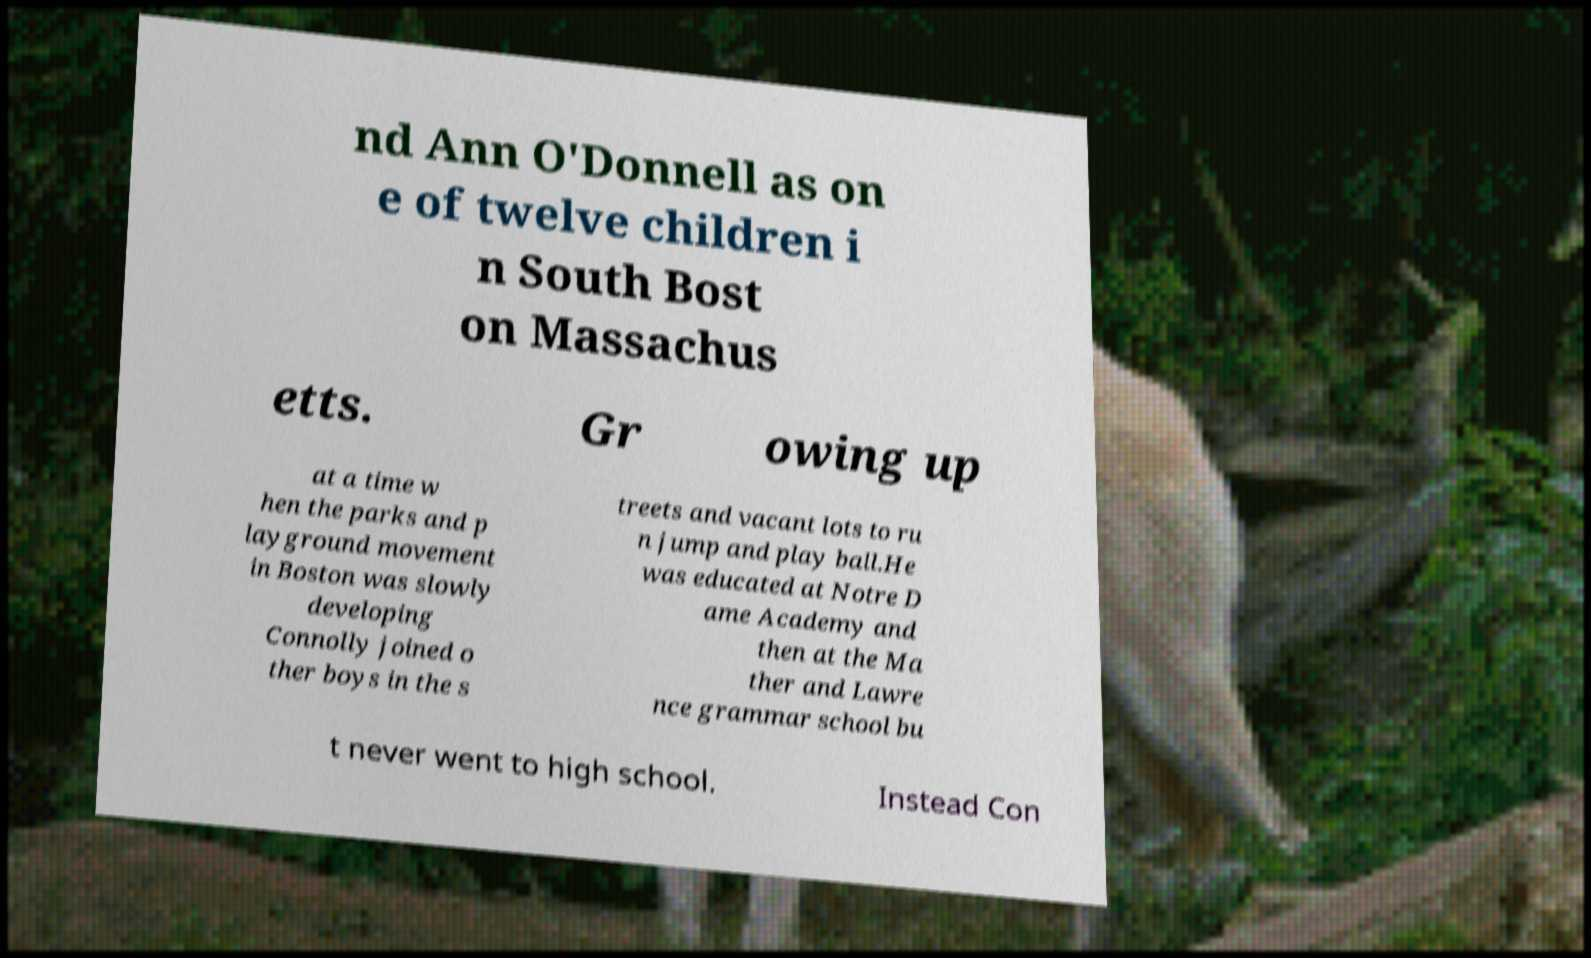I need the written content from this picture converted into text. Can you do that? nd Ann O'Donnell as on e of twelve children i n South Bost on Massachus etts. Gr owing up at a time w hen the parks and p layground movement in Boston was slowly developing Connolly joined o ther boys in the s treets and vacant lots to ru n jump and play ball.He was educated at Notre D ame Academy and then at the Ma ther and Lawre nce grammar school bu t never went to high school. Instead Con 